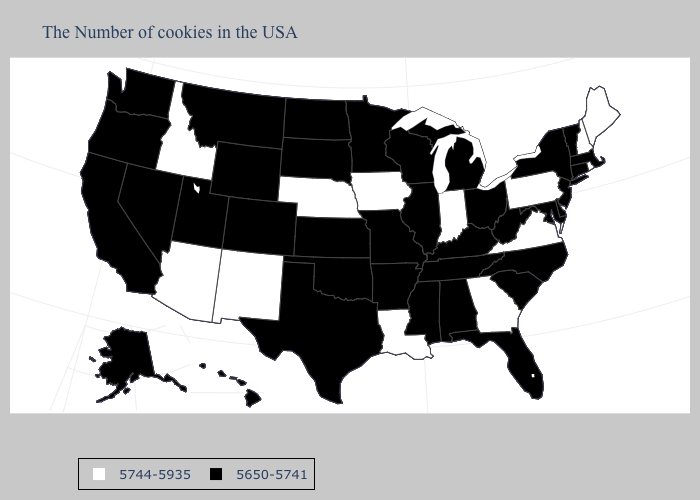Which states hav the highest value in the MidWest?
Write a very short answer. Indiana, Iowa, Nebraska. Name the states that have a value in the range 5650-5741?
Concise answer only. Massachusetts, Vermont, Connecticut, New York, New Jersey, Delaware, Maryland, North Carolina, South Carolina, West Virginia, Ohio, Florida, Michigan, Kentucky, Alabama, Tennessee, Wisconsin, Illinois, Mississippi, Missouri, Arkansas, Minnesota, Kansas, Oklahoma, Texas, South Dakota, North Dakota, Wyoming, Colorado, Utah, Montana, Nevada, California, Washington, Oregon, Alaska, Hawaii. Does the first symbol in the legend represent the smallest category?
Answer briefly. No. What is the value of Georgia?
Quick response, please. 5744-5935. What is the highest value in the MidWest ?
Give a very brief answer. 5744-5935. What is the highest value in states that border Vermont?
Short answer required. 5744-5935. What is the value of New Mexico?
Give a very brief answer. 5744-5935. What is the lowest value in the South?
Keep it brief. 5650-5741. What is the value of West Virginia?
Answer briefly. 5650-5741. Which states have the lowest value in the USA?
Short answer required. Massachusetts, Vermont, Connecticut, New York, New Jersey, Delaware, Maryland, North Carolina, South Carolina, West Virginia, Ohio, Florida, Michigan, Kentucky, Alabama, Tennessee, Wisconsin, Illinois, Mississippi, Missouri, Arkansas, Minnesota, Kansas, Oklahoma, Texas, South Dakota, North Dakota, Wyoming, Colorado, Utah, Montana, Nevada, California, Washington, Oregon, Alaska, Hawaii. What is the highest value in the USA?
Short answer required. 5744-5935. What is the lowest value in states that border Massachusetts?
Short answer required. 5650-5741. Which states have the lowest value in the MidWest?
Write a very short answer. Ohio, Michigan, Wisconsin, Illinois, Missouri, Minnesota, Kansas, South Dakota, North Dakota. What is the value of Hawaii?
Write a very short answer. 5650-5741. Is the legend a continuous bar?
Give a very brief answer. No. 